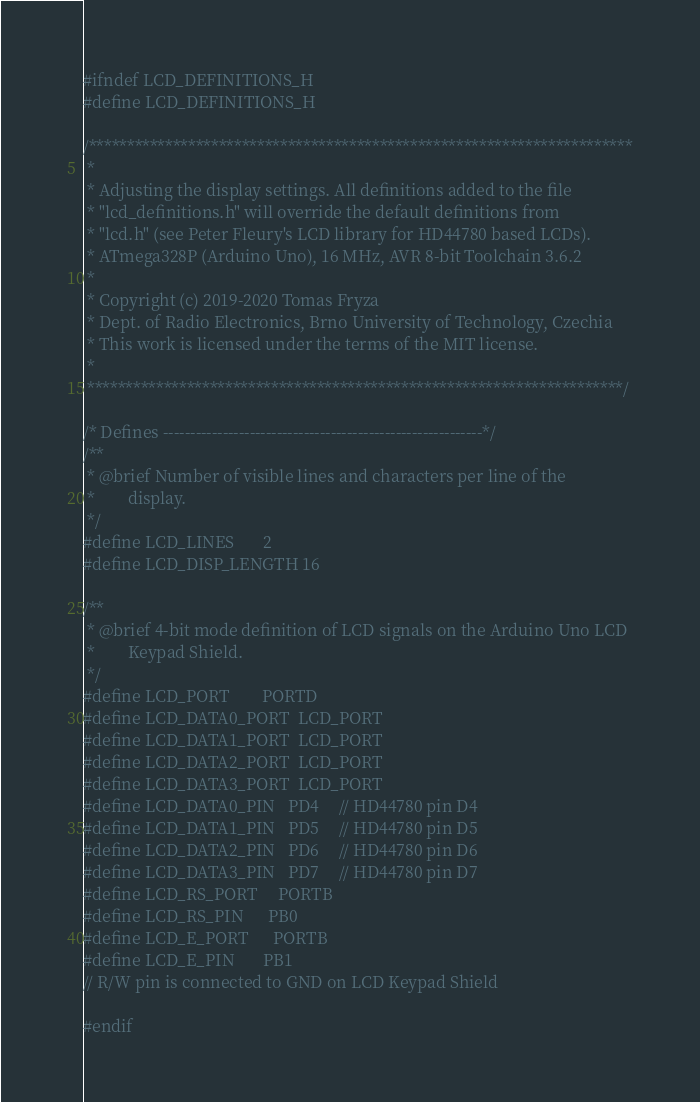Convert code to text. <code><loc_0><loc_0><loc_500><loc_500><_C_>#ifndef LCD_DEFINITIONS_H
#define LCD_DEFINITIONS_H

/***********************************************************************
 * 
 * Adjusting the display settings. All definitions added to the file 
 * "lcd_definitions.h" will override the default definitions from 
 * "lcd.h" (see Peter Fleury's LCD library for HD44780 based LCDs).
 * ATmega328P (Arduino Uno), 16 MHz, AVR 8-bit Toolchain 3.6.2
 *
 * Copyright (c) 2019-2020 Tomas Fryza
 * Dept. of Radio Electronics, Brno University of Technology, Czechia
 * This work is licensed under the terms of the MIT license.
 *
 **********************************************************************/

/* Defines -----------------------------------------------------------*/
/**
 * @brief Number of visible lines and characters per line of the 
 *        display.
 */
#define LCD_LINES       2
#define LCD_DISP_LENGTH 16

/**
 * @brief 4-bit mode definition of LCD signals on the Arduino Uno LCD
 *        Keypad Shield.
 */
#define LCD_PORT        PORTD
#define LCD_DATA0_PORT  LCD_PORT
#define LCD_DATA1_PORT  LCD_PORT
#define LCD_DATA2_PORT  LCD_PORT
#define LCD_DATA3_PORT  LCD_PORT
#define LCD_DATA0_PIN   PD4     // HD44780 pin D4
#define LCD_DATA1_PIN   PD5     // HD44780 pin D5
#define LCD_DATA2_PIN   PD6     // HD44780 pin D6
#define LCD_DATA3_PIN   PD7     // HD44780 pin D7
#define LCD_RS_PORT     PORTB
#define LCD_RS_PIN      PB0
#define LCD_E_PORT      PORTB
#define LCD_E_PIN       PB1
// R/W pin is connected to GND on LCD Keypad Shield

#endif</code> 